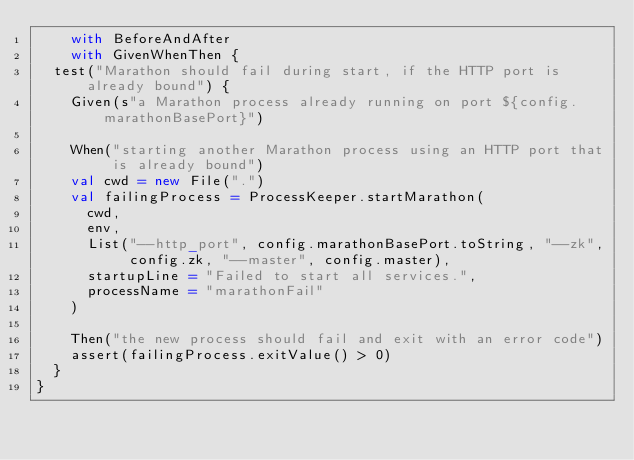Convert code to text. <code><loc_0><loc_0><loc_500><loc_500><_Scala_>    with BeforeAndAfter
    with GivenWhenThen {
  test("Marathon should fail during start, if the HTTP port is already bound") {
    Given(s"a Marathon process already running on port ${config.marathonBasePort}")

    When("starting another Marathon process using an HTTP port that is already bound")
    val cwd = new File(".")
    val failingProcess = ProcessKeeper.startMarathon(
      cwd,
      env,
      List("--http_port", config.marathonBasePort.toString, "--zk", config.zk, "--master", config.master),
      startupLine = "Failed to start all services.",
      processName = "marathonFail"
    )

    Then("the new process should fail and exit with an error code")
    assert(failingProcess.exitValue() > 0)
  }
}
</code> 